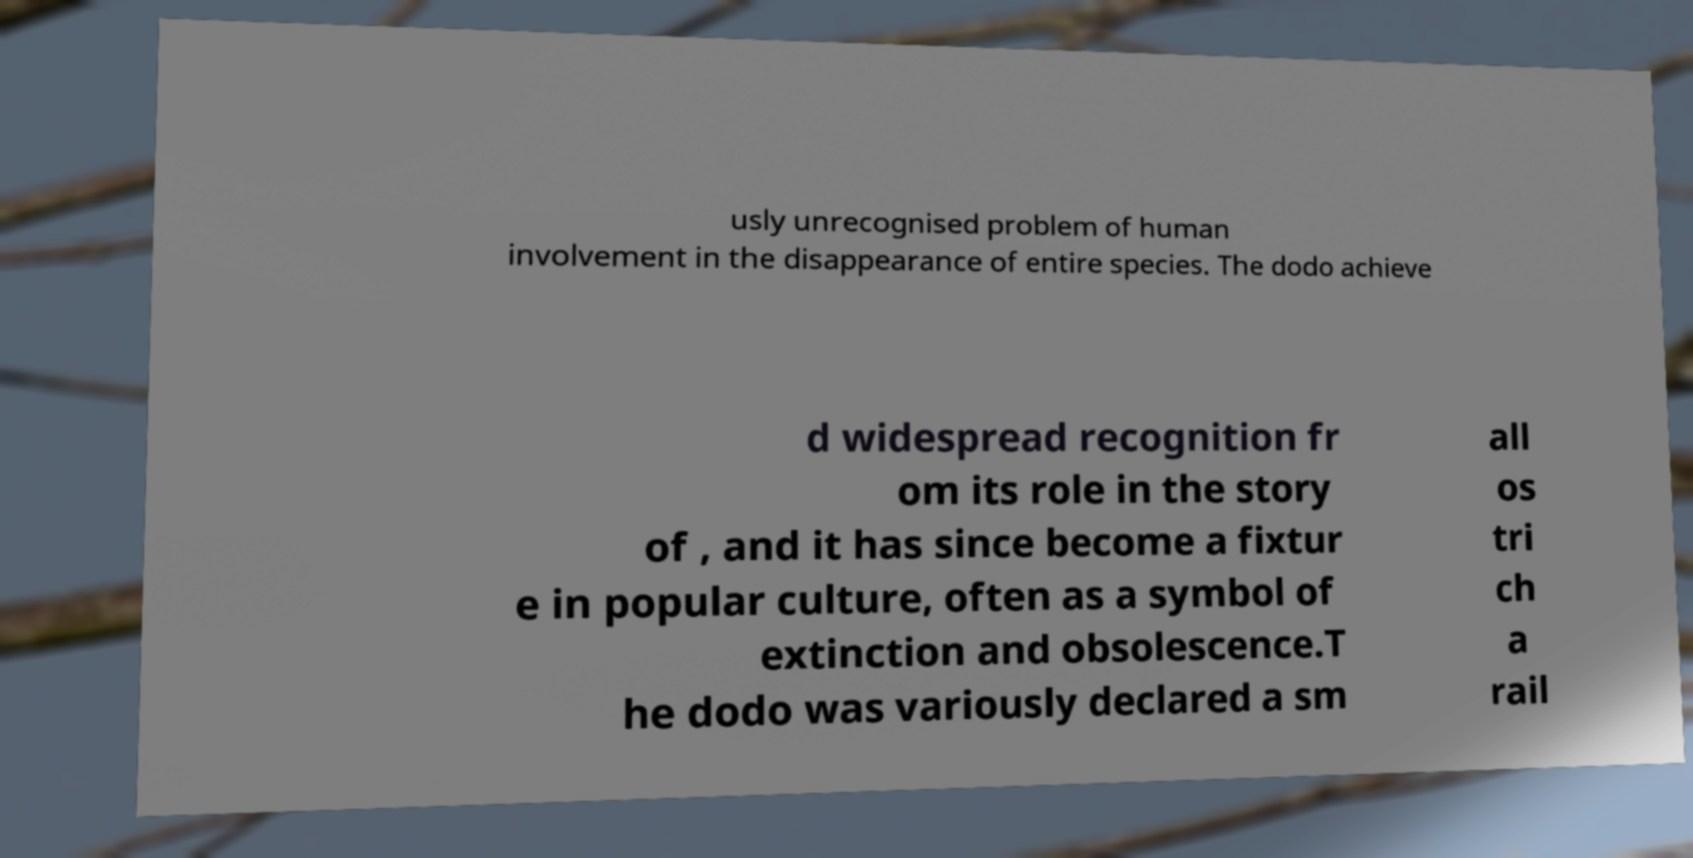Please read and relay the text visible in this image. What does it say? usly unrecognised problem of human involvement in the disappearance of entire species. The dodo achieve d widespread recognition fr om its role in the story of , and it has since become a fixtur e in popular culture, often as a symbol of extinction and obsolescence.T he dodo was variously declared a sm all os tri ch a rail 